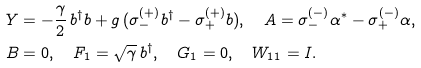<formula> <loc_0><loc_0><loc_500><loc_500>& Y = - \frac { \gamma } { 2 } \, b ^ { \dag } b + g \, ( \sigma _ { - } ^ { ( + ) } b ^ { \dag } - \sigma _ { + } ^ { ( + ) } b ) , \quad A = \sigma _ { - } ^ { ( - ) } \alpha ^ { * } - \sigma _ { + } ^ { ( - ) } \alpha , \\ & B = 0 , \quad F _ { 1 } = \sqrt { \gamma } \, b ^ { \dag } , \quad G _ { 1 } = 0 , \quad W _ { 1 1 } = I .</formula> 